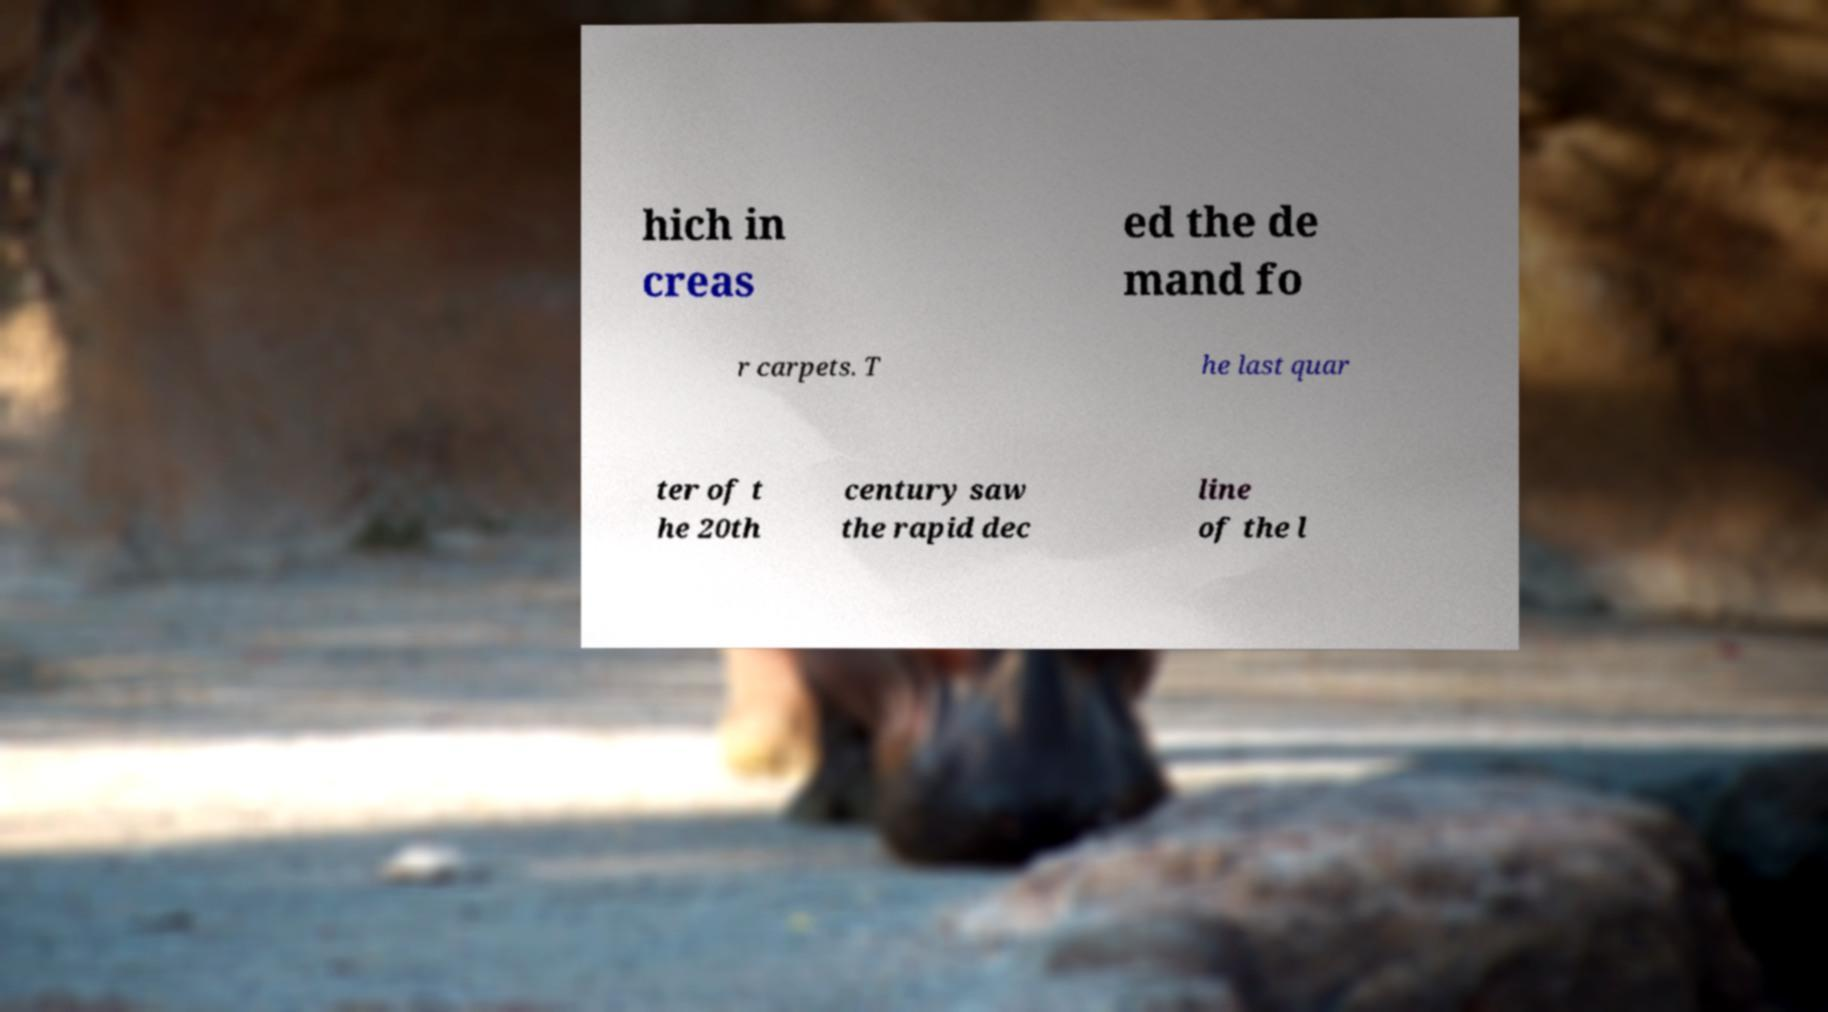Can you read and provide the text displayed in the image?This photo seems to have some interesting text. Can you extract and type it out for me? hich in creas ed the de mand fo r carpets. T he last quar ter of t he 20th century saw the rapid dec line of the l 